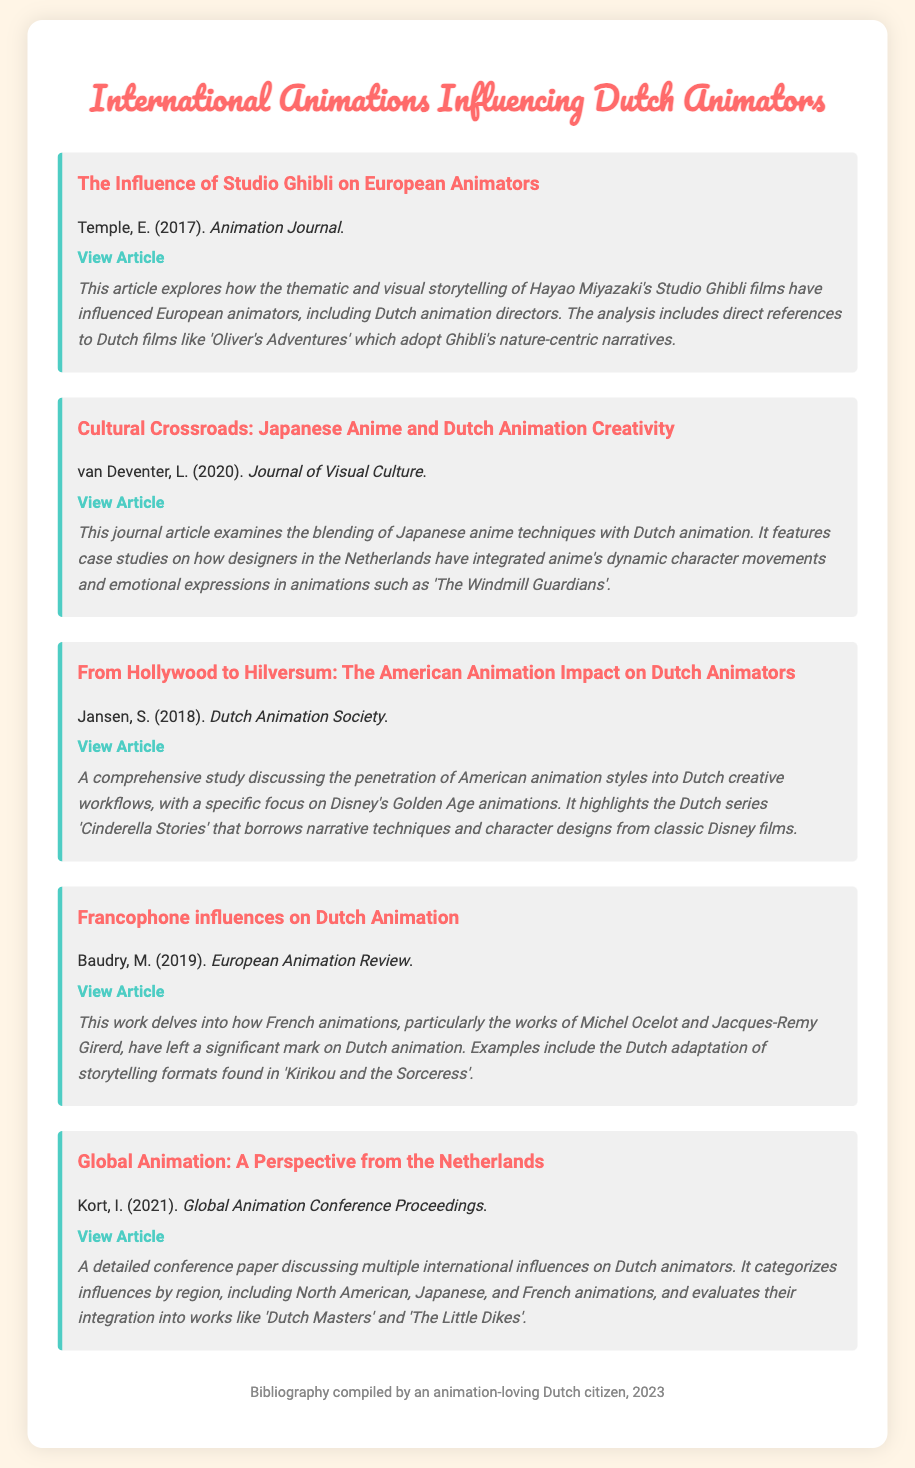What is the title of the first bibliography item? The first bibliography item is titled "The Influence of Studio Ghibli on European Animators."
Answer: The Influence of Studio Ghibli on European Animators Who is the author of the article related to Japanese anime and Dutch animation creativity? The author of the article is L. van Deventer.
Answer: L. van Deventer In which year was the article about American animation's impact on Dutch animators published? The article was published in 2018.
Answer: 2018 What is a key example from the article discussing Francophone influences on Dutch Animation? The key example mentioned is the Dutch adaptation of "Kirikou and the Sorceress."
Answer: Kirikou and the Sorceress What type of document is this bibliography categorized under? The document is categorized as a bibliography.
Answer: bibliography How many bibliography items discuss the influence of Japanese animation? There are two items that discuss the influence of Japanese animation.
Answer: 2 Which publication includes the article "Global Animation: A Perspective from the Netherlands"? The article is included in the "Global Animation Conference Proceedings."
Answer: Global Animation Conference Proceedings What is the main focus of Jansen's article? The main focus is on the impact of American animation on Dutch animators.
Answer: the impact of American animation on Dutch animators 